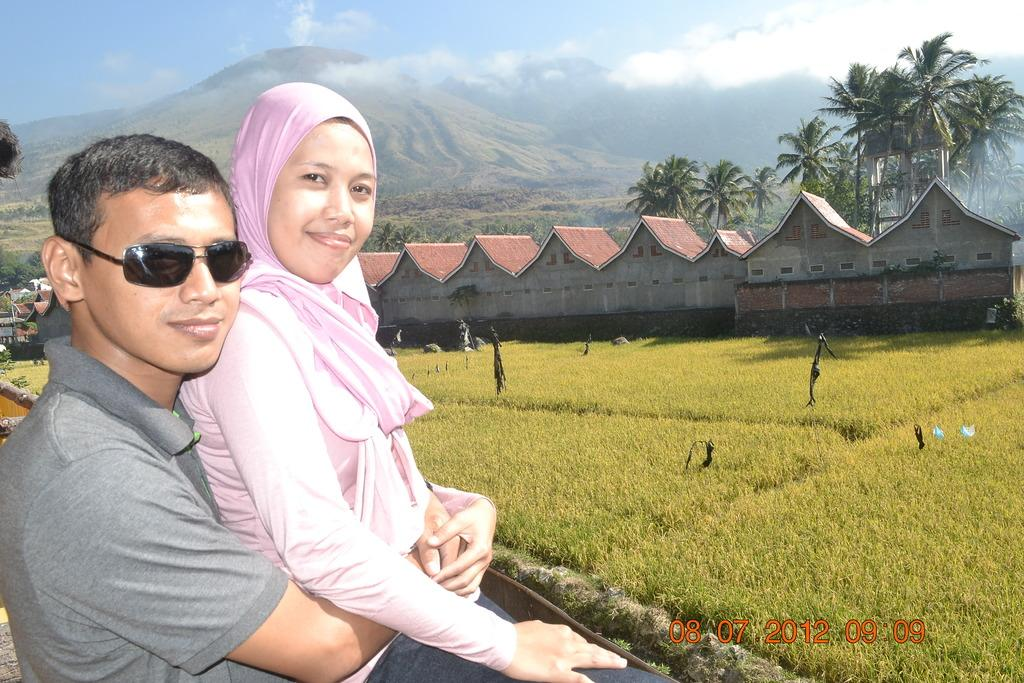What are the two people in the image doing? There is a man and a woman sitting in the image. What type of terrain is visible in the image? There is grass on the ground, and there are hills in the image. What type of structures can be seen in the image? There are homes visible in the image. What type of vegetation is present in the image? Trees are present in the image. What is visible in the sky in the image? Clouds are visible in the sky. What type of wound can be seen on the baby's arm in the image? There are no babies present in the image, and therefore no wounds can be observed. What type of teeth can be seen in the image? There are no teeth visible in the image. 